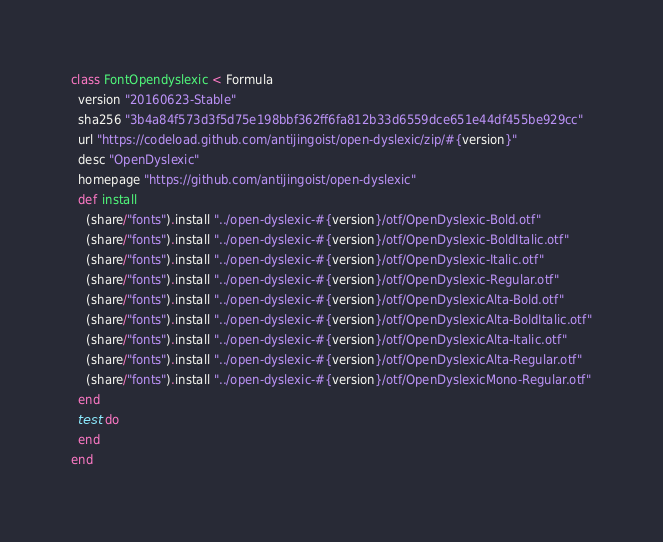<code> <loc_0><loc_0><loc_500><loc_500><_Ruby_>class FontOpendyslexic < Formula
  version "20160623-Stable"
  sha256 "3b4a84f573d3f5d75e198bbf362ff6fa812b33d6559dce651e44df455be929cc"
  url "https://codeload.github.com/antijingoist/open-dyslexic/zip/#{version}"
  desc "OpenDyslexic"
  homepage "https://github.com/antijingoist/open-dyslexic"
  def install
    (share/"fonts").install "../open-dyslexic-#{version}/otf/OpenDyslexic-Bold.otf"
    (share/"fonts").install "../open-dyslexic-#{version}/otf/OpenDyslexic-BoldItalic.otf"
    (share/"fonts").install "../open-dyslexic-#{version}/otf/OpenDyslexic-Italic.otf"
    (share/"fonts").install "../open-dyslexic-#{version}/otf/OpenDyslexic-Regular.otf"
    (share/"fonts").install "../open-dyslexic-#{version}/otf/OpenDyslexicAlta-Bold.otf"
    (share/"fonts").install "../open-dyslexic-#{version}/otf/OpenDyslexicAlta-BoldItalic.otf"
    (share/"fonts").install "../open-dyslexic-#{version}/otf/OpenDyslexicAlta-Italic.otf"
    (share/"fonts").install "../open-dyslexic-#{version}/otf/OpenDyslexicAlta-Regular.otf"
    (share/"fonts").install "../open-dyslexic-#{version}/otf/OpenDyslexicMono-Regular.otf"
  end
  test do
  end
end
</code> 